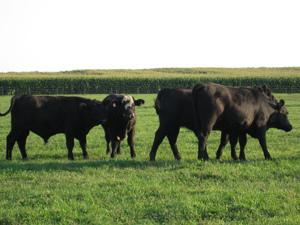What differentiates the black cow with white face from the other cows in the image? That cow has a white spot on its face while the others do not. Using 2 adjectives, describe the sky in the image. The sky is bright and clear. What kind of landscape can be seen in the image? A pasture with cows grazing, a corn field behind them, and a clear blue sky above. How many clouds appear in the blue sky? There are no clouds in the blue sky. What color is the fur of the cows in the image? The cows have black fur. Give a general description of the scene depicted in the image. The image shows cows with black fur grazing in a green and thick grassy field with tall corn stalks behind them and a clear, blue sky overhead. Tell me something particular about the appearance of the cows in this picture. The cows have dark legs, dark ears, dark noses, and a white spot on the face. What type of animals can be seen in the image? Four cows can be seen in the image. Can you tell me something about the vegetation in this picture? There are tall green corn stalks and thick green grass in the image. Mention one of the objects near the rear and front leg of the black cow. For the rear leg, there is an udder, and for the front leg, there is a fence separating the grassy area from the corn. 